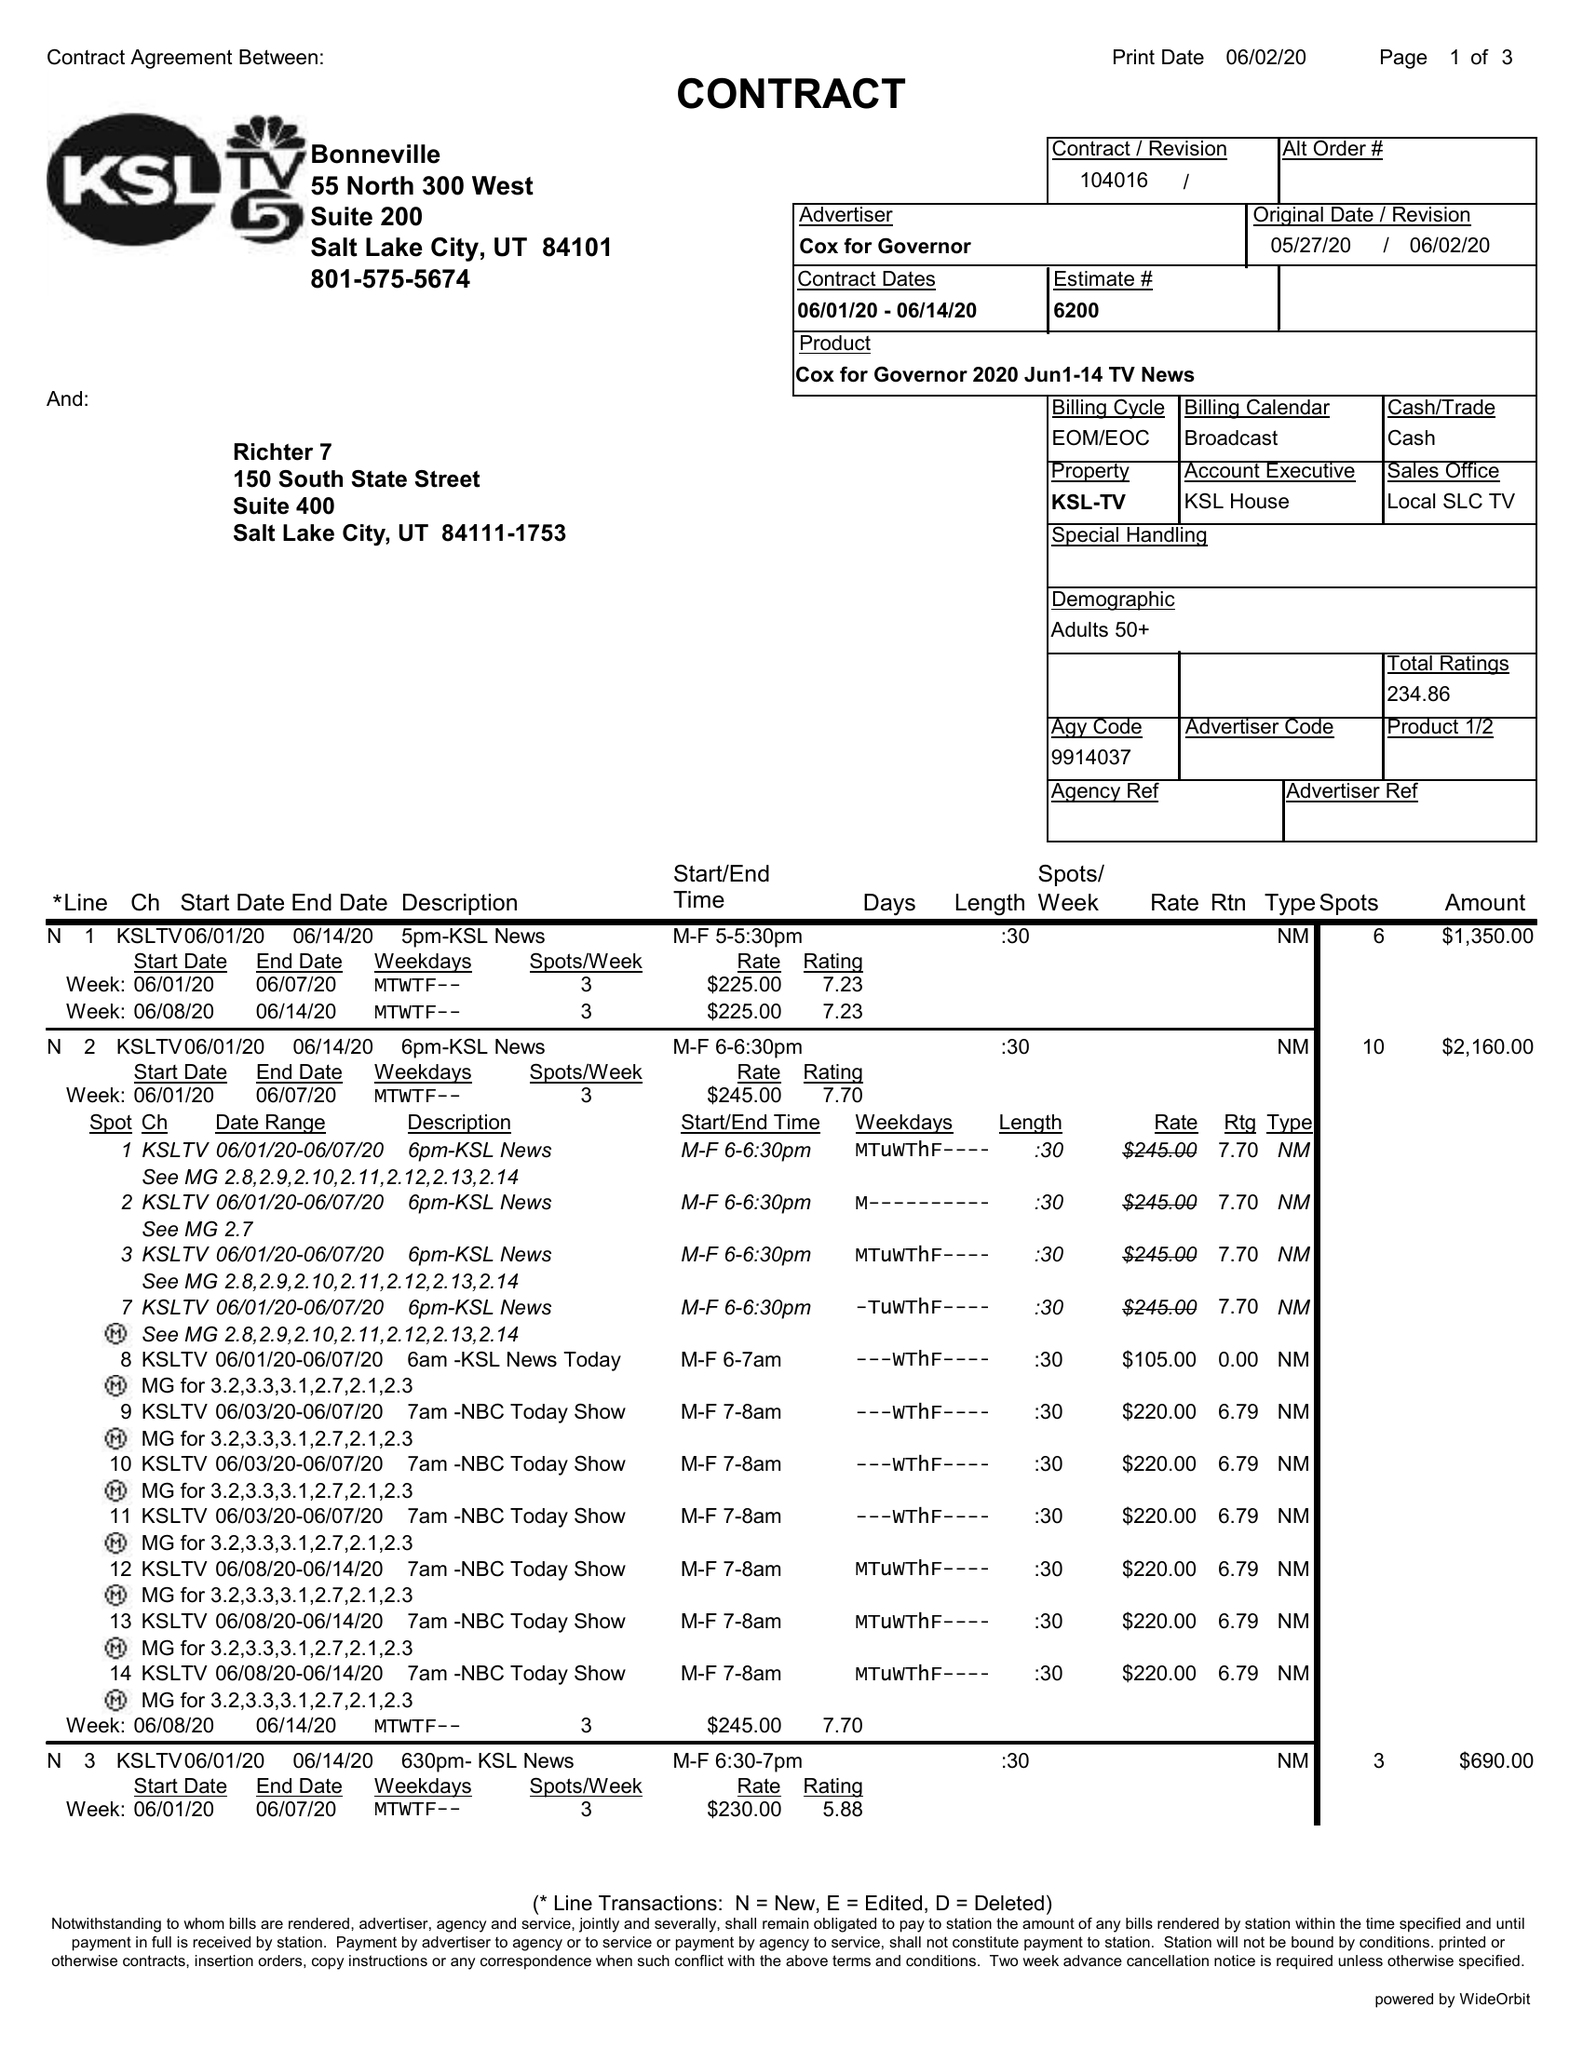What is the value for the advertiser?
Answer the question using a single word or phrase. COX FOR GOVERNOR 